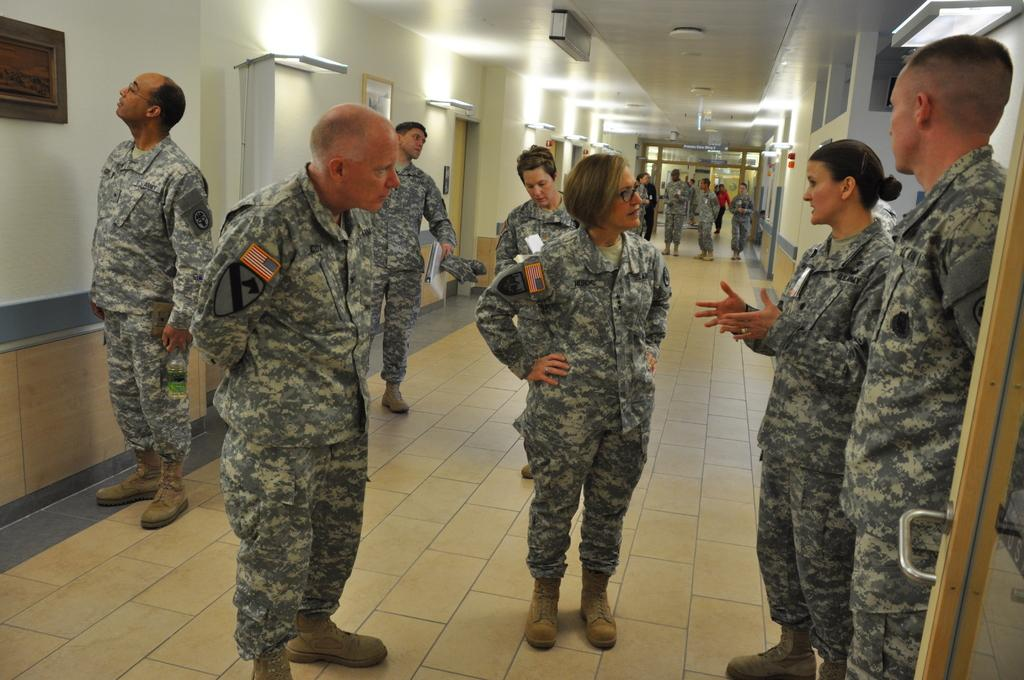How many people are in the image? There is a group of people in the image, but the exact number is not specified. What are the people in the image doing? Some people are standing, while others are walking. What can be seen on the wall in the image? There are frames on the wall in the image. What is visible in the background of the image? There are lights visible in the background of the image. What type of pencil can be seen being used by the people in the image? There is no pencil visible in the image; the people are either standing or walking. Can you describe the clouds in the image? There are no clouds present in the image. 